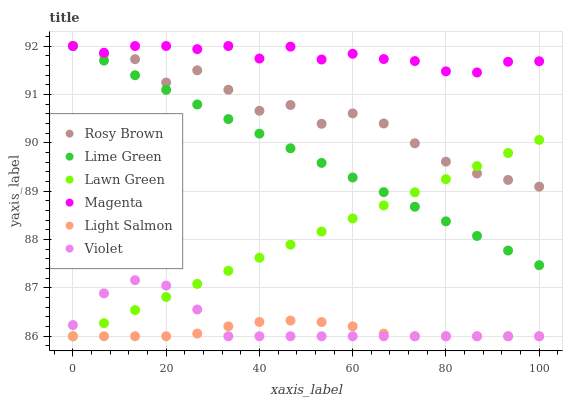Does Light Salmon have the minimum area under the curve?
Answer yes or no. Yes. Does Magenta have the maximum area under the curve?
Answer yes or no. Yes. Does Rosy Brown have the minimum area under the curve?
Answer yes or no. No. Does Rosy Brown have the maximum area under the curve?
Answer yes or no. No. Is Lime Green the smoothest?
Answer yes or no. Yes. Is Rosy Brown the roughest?
Answer yes or no. Yes. Is Light Salmon the smoothest?
Answer yes or no. No. Is Light Salmon the roughest?
Answer yes or no. No. Does Lawn Green have the lowest value?
Answer yes or no. Yes. Does Rosy Brown have the lowest value?
Answer yes or no. No. Does Lime Green have the highest value?
Answer yes or no. Yes. Does Light Salmon have the highest value?
Answer yes or no. No. Is Light Salmon less than Rosy Brown?
Answer yes or no. Yes. Is Magenta greater than Light Salmon?
Answer yes or no. Yes. Does Violet intersect Light Salmon?
Answer yes or no. Yes. Is Violet less than Light Salmon?
Answer yes or no. No. Is Violet greater than Light Salmon?
Answer yes or no. No. Does Light Salmon intersect Rosy Brown?
Answer yes or no. No. 